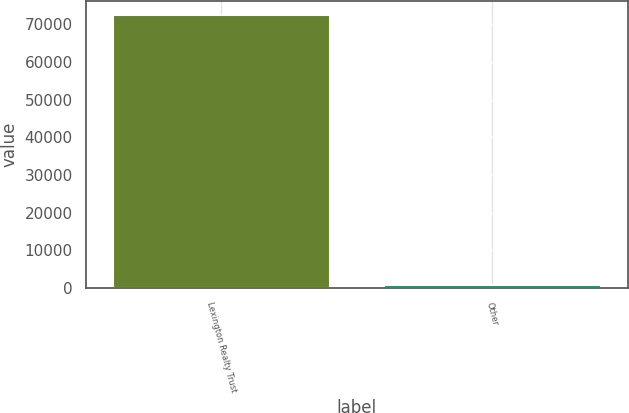Convert chart to OTSL. <chart><loc_0><loc_0><loc_500><loc_500><bar_chart><fcel>Lexington Realty Trust<fcel>Other<nl><fcel>72549<fcel>650<nl></chart> 